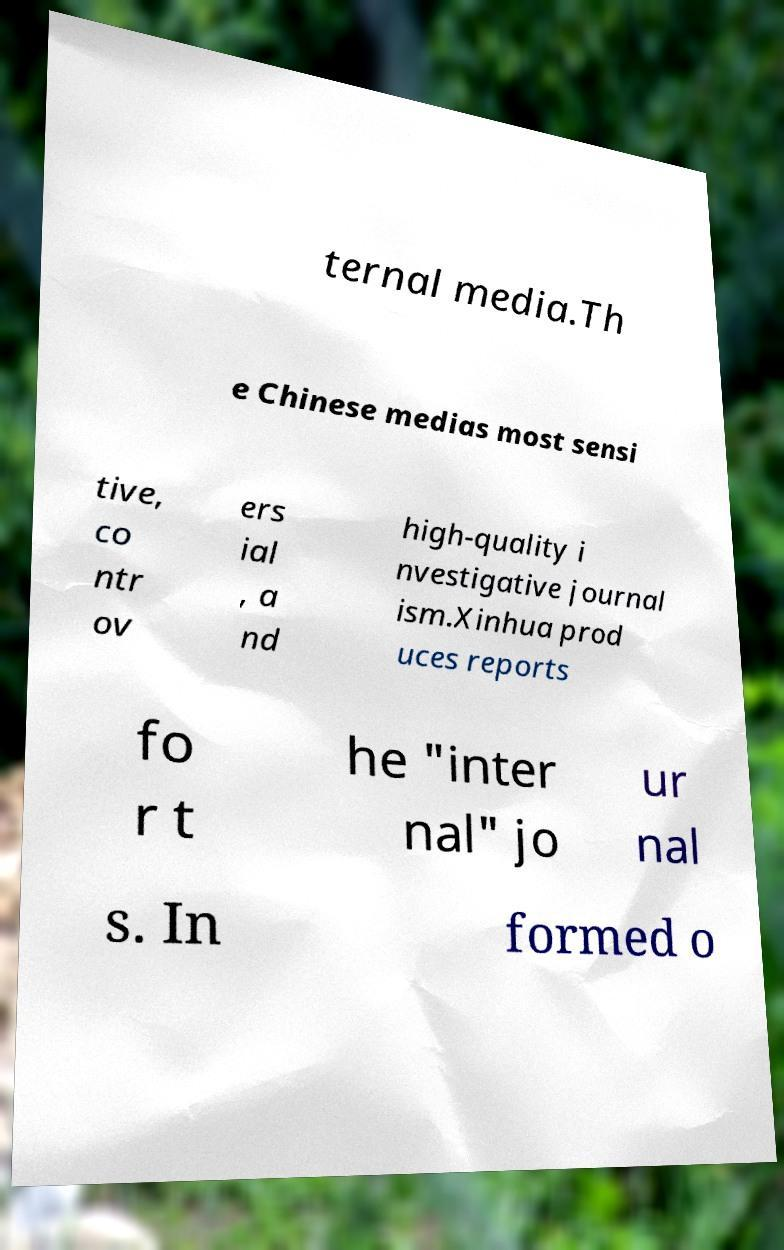There's text embedded in this image that I need extracted. Can you transcribe it verbatim? ternal media.Th e Chinese medias most sensi tive, co ntr ov ers ial , a nd high-quality i nvestigative journal ism.Xinhua prod uces reports fo r t he "inter nal" jo ur nal s. In formed o 